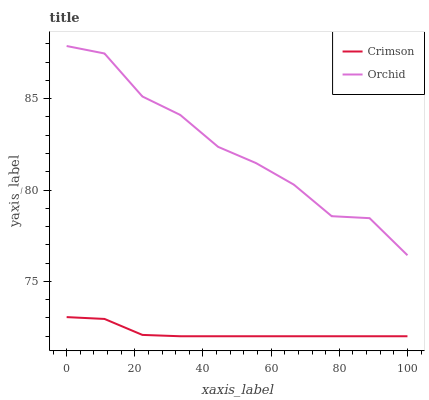Does Orchid have the minimum area under the curve?
Answer yes or no. No. Is Orchid the smoothest?
Answer yes or no. No. Does Orchid have the lowest value?
Answer yes or no. No. Is Crimson less than Orchid?
Answer yes or no. Yes. Is Orchid greater than Crimson?
Answer yes or no. Yes. Does Crimson intersect Orchid?
Answer yes or no. No. 